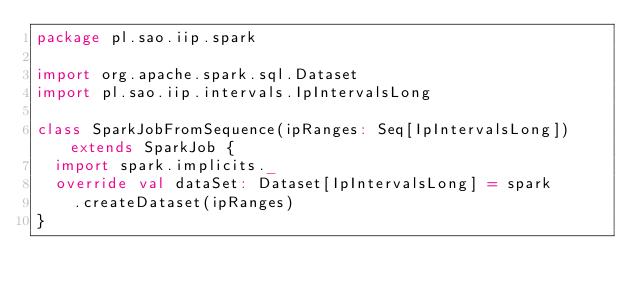Convert code to text. <code><loc_0><loc_0><loc_500><loc_500><_Scala_>package pl.sao.iip.spark

import org.apache.spark.sql.Dataset
import pl.sao.iip.intervals.IpIntervalsLong

class SparkJobFromSequence(ipRanges: Seq[IpIntervalsLong]) extends SparkJob {
  import spark.implicits._
  override val dataSet: Dataset[IpIntervalsLong] = spark
    .createDataset(ipRanges)
}
</code> 